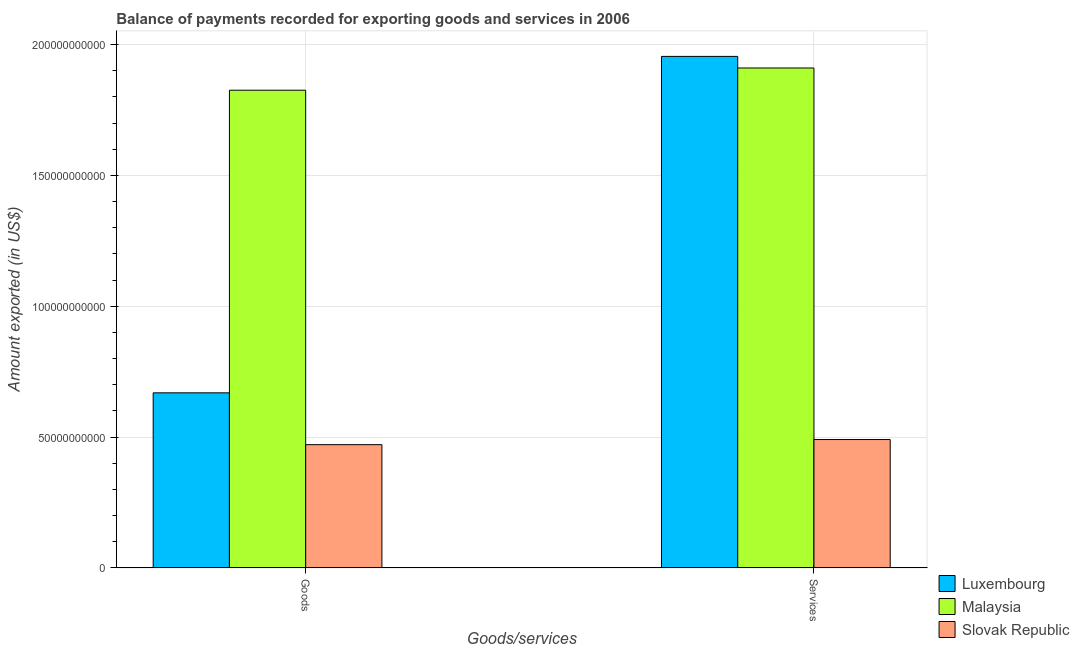How many different coloured bars are there?
Keep it short and to the point. 3. How many groups of bars are there?
Make the answer very short. 2. Are the number of bars on each tick of the X-axis equal?
Your answer should be very brief. Yes. How many bars are there on the 1st tick from the left?
Offer a very short reply. 3. How many bars are there on the 1st tick from the right?
Your answer should be compact. 3. What is the label of the 2nd group of bars from the left?
Your response must be concise. Services. What is the amount of goods exported in Slovak Republic?
Give a very brief answer. 4.71e+1. Across all countries, what is the maximum amount of services exported?
Provide a succinct answer. 1.95e+11. Across all countries, what is the minimum amount of services exported?
Ensure brevity in your answer.  4.91e+1. In which country was the amount of services exported maximum?
Offer a very short reply. Luxembourg. In which country was the amount of services exported minimum?
Provide a succinct answer. Slovak Republic. What is the total amount of goods exported in the graph?
Make the answer very short. 2.97e+11. What is the difference between the amount of services exported in Slovak Republic and that in Malaysia?
Keep it short and to the point. -1.42e+11. What is the difference between the amount of goods exported in Luxembourg and the amount of services exported in Malaysia?
Give a very brief answer. -1.24e+11. What is the average amount of goods exported per country?
Offer a terse response. 9.89e+1. What is the difference between the amount of goods exported and amount of services exported in Slovak Republic?
Provide a short and direct response. -1.96e+09. What is the ratio of the amount of services exported in Malaysia to that in Luxembourg?
Keep it short and to the point. 0.98. Is the amount of goods exported in Luxembourg less than that in Slovak Republic?
Your answer should be compact. No. In how many countries, is the amount of services exported greater than the average amount of services exported taken over all countries?
Your answer should be very brief. 2. What does the 1st bar from the left in Services represents?
Your answer should be compact. Luxembourg. What does the 2nd bar from the right in Goods represents?
Provide a succinct answer. Malaysia. What is the difference between two consecutive major ticks on the Y-axis?
Make the answer very short. 5.00e+1. Are the values on the major ticks of Y-axis written in scientific E-notation?
Give a very brief answer. No. Does the graph contain any zero values?
Offer a terse response. No. What is the title of the graph?
Ensure brevity in your answer.  Balance of payments recorded for exporting goods and services in 2006. Does "Zimbabwe" appear as one of the legend labels in the graph?
Your response must be concise. No. What is the label or title of the X-axis?
Your answer should be very brief. Goods/services. What is the label or title of the Y-axis?
Provide a succinct answer. Amount exported (in US$). What is the Amount exported (in US$) in Luxembourg in Goods?
Give a very brief answer. 6.69e+1. What is the Amount exported (in US$) in Malaysia in Goods?
Offer a terse response. 1.83e+11. What is the Amount exported (in US$) in Slovak Republic in Goods?
Provide a short and direct response. 4.71e+1. What is the Amount exported (in US$) of Luxembourg in Services?
Offer a terse response. 1.95e+11. What is the Amount exported (in US$) of Malaysia in Services?
Ensure brevity in your answer.  1.91e+11. What is the Amount exported (in US$) of Slovak Republic in Services?
Make the answer very short. 4.91e+1. Across all Goods/services, what is the maximum Amount exported (in US$) of Luxembourg?
Your answer should be very brief. 1.95e+11. Across all Goods/services, what is the maximum Amount exported (in US$) of Malaysia?
Ensure brevity in your answer.  1.91e+11. Across all Goods/services, what is the maximum Amount exported (in US$) of Slovak Republic?
Make the answer very short. 4.91e+1. Across all Goods/services, what is the minimum Amount exported (in US$) of Luxembourg?
Your response must be concise. 6.69e+1. Across all Goods/services, what is the minimum Amount exported (in US$) of Malaysia?
Your answer should be compact. 1.83e+11. Across all Goods/services, what is the minimum Amount exported (in US$) of Slovak Republic?
Offer a terse response. 4.71e+1. What is the total Amount exported (in US$) in Luxembourg in the graph?
Provide a short and direct response. 2.62e+11. What is the total Amount exported (in US$) in Malaysia in the graph?
Keep it short and to the point. 3.74e+11. What is the total Amount exported (in US$) of Slovak Republic in the graph?
Keep it short and to the point. 9.62e+1. What is the difference between the Amount exported (in US$) of Luxembourg in Goods and that in Services?
Make the answer very short. -1.29e+11. What is the difference between the Amount exported (in US$) of Malaysia in Goods and that in Services?
Your answer should be compact. -8.49e+09. What is the difference between the Amount exported (in US$) in Slovak Republic in Goods and that in Services?
Your response must be concise. -1.96e+09. What is the difference between the Amount exported (in US$) in Luxembourg in Goods and the Amount exported (in US$) in Malaysia in Services?
Make the answer very short. -1.24e+11. What is the difference between the Amount exported (in US$) in Luxembourg in Goods and the Amount exported (in US$) in Slovak Republic in Services?
Provide a short and direct response. 1.78e+1. What is the difference between the Amount exported (in US$) in Malaysia in Goods and the Amount exported (in US$) in Slovak Republic in Services?
Give a very brief answer. 1.33e+11. What is the average Amount exported (in US$) in Luxembourg per Goods/services?
Offer a terse response. 1.31e+11. What is the average Amount exported (in US$) in Malaysia per Goods/services?
Give a very brief answer. 1.87e+11. What is the average Amount exported (in US$) in Slovak Republic per Goods/services?
Provide a succinct answer. 4.81e+1. What is the difference between the Amount exported (in US$) of Luxembourg and Amount exported (in US$) of Malaysia in Goods?
Your response must be concise. -1.16e+11. What is the difference between the Amount exported (in US$) of Luxembourg and Amount exported (in US$) of Slovak Republic in Goods?
Give a very brief answer. 1.98e+1. What is the difference between the Amount exported (in US$) of Malaysia and Amount exported (in US$) of Slovak Republic in Goods?
Offer a very short reply. 1.35e+11. What is the difference between the Amount exported (in US$) in Luxembourg and Amount exported (in US$) in Malaysia in Services?
Your answer should be very brief. 4.43e+09. What is the difference between the Amount exported (in US$) of Luxembourg and Amount exported (in US$) of Slovak Republic in Services?
Provide a succinct answer. 1.46e+11. What is the difference between the Amount exported (in US$) in Malaysia and Amount exported (in US$) in Slovak Republic in Services?
Your answer should be very brief. 1.42e+11. What is the ratio of the Amount exported (in US$) in Luxembourg in Goods to that in Services?
Provide a succinct answer. 0.34. What is the ratio of the Amount exported (in US$) of Malaysia in Goods to that in Services?
Your response must be concise. 0.96. What is the ratio of the Amount exported (in US$) of Slovak Republic in Goods to that in Services?
Provide a short and direct response. 0.96. What is the difference between the highest and the second highest Amount exported (in US$) in Luxembourg?
Offer a very short reply. 1.29e+11. What is the difference between the highest and the second highest Amount exported (in US$) in Malaysia?
Offer a terse response. 8.49e+09. What is the difference between the highest and the second highest Amount exported (in US$) of Slovak Republic?
Ensure brevity in your answer.  1.96e+09. What is the difference between the highest and the lowest Amount exported (in US$) of Luxembourg?
Your answer should be compact. 1.29e+11. What is the difference between the highest and the lowest Amount exported (in US$) in Malaysia?
Ensure brevity in your answer.  8.49e+09. What is the difference between the highest and the lowest Amount exported (in US$) of Slovak Republic?
Give a very brief answer. 1.96e+09. 